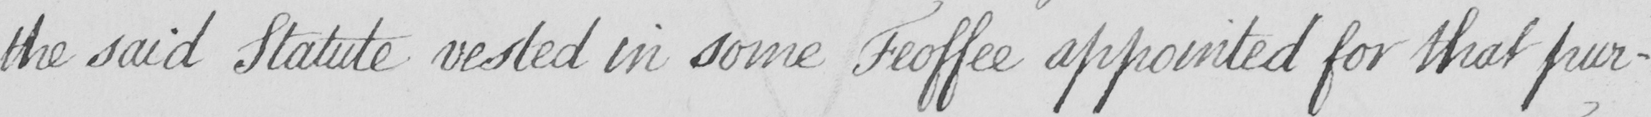What is written in this line of handwriting? the said Statute vested in some Feoffee appointed for that pur- 